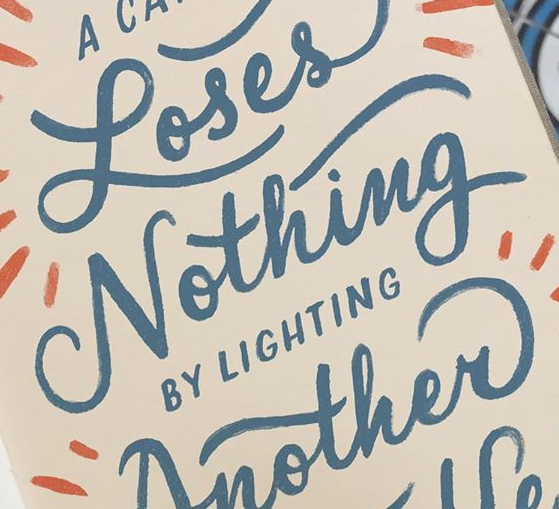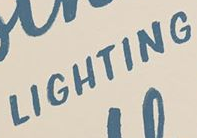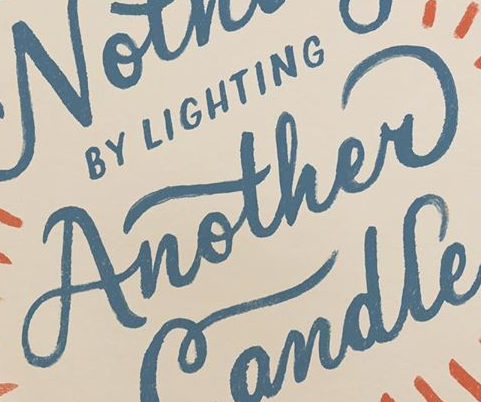What words can you see in these images in sequence, separated by a semicolon? Nothing; LIGHTING; Another 